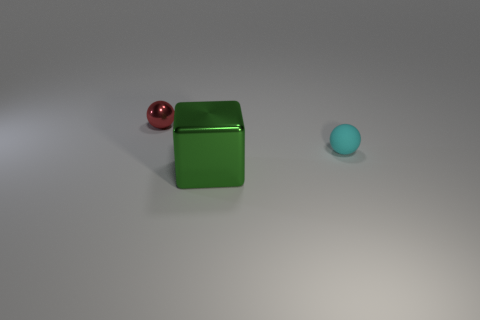Add 2 cyan objects. How many cyan objects exist? 3 Add 2 brown cylinders. How many objects exist? 5 Subtract all cyan balls. How many balls are left? 1 Subtract 0 brown cylinders. How many objects are left? 3 Subtract all cubes. How many objects are left? 2 Subtract 1 blocks. How many blocks are left? 0 Subtract all gray cubes. Subtract all gray cylinders. How many cubes are left? 1 Subtract all yellow blocks. How many blue balls are left? 0 Subtract all tiny shiny spheres. Subtract all tiny cyan objects. How many objects are left? 1 Add 2 large green objects. How many large green objects are left? 3 